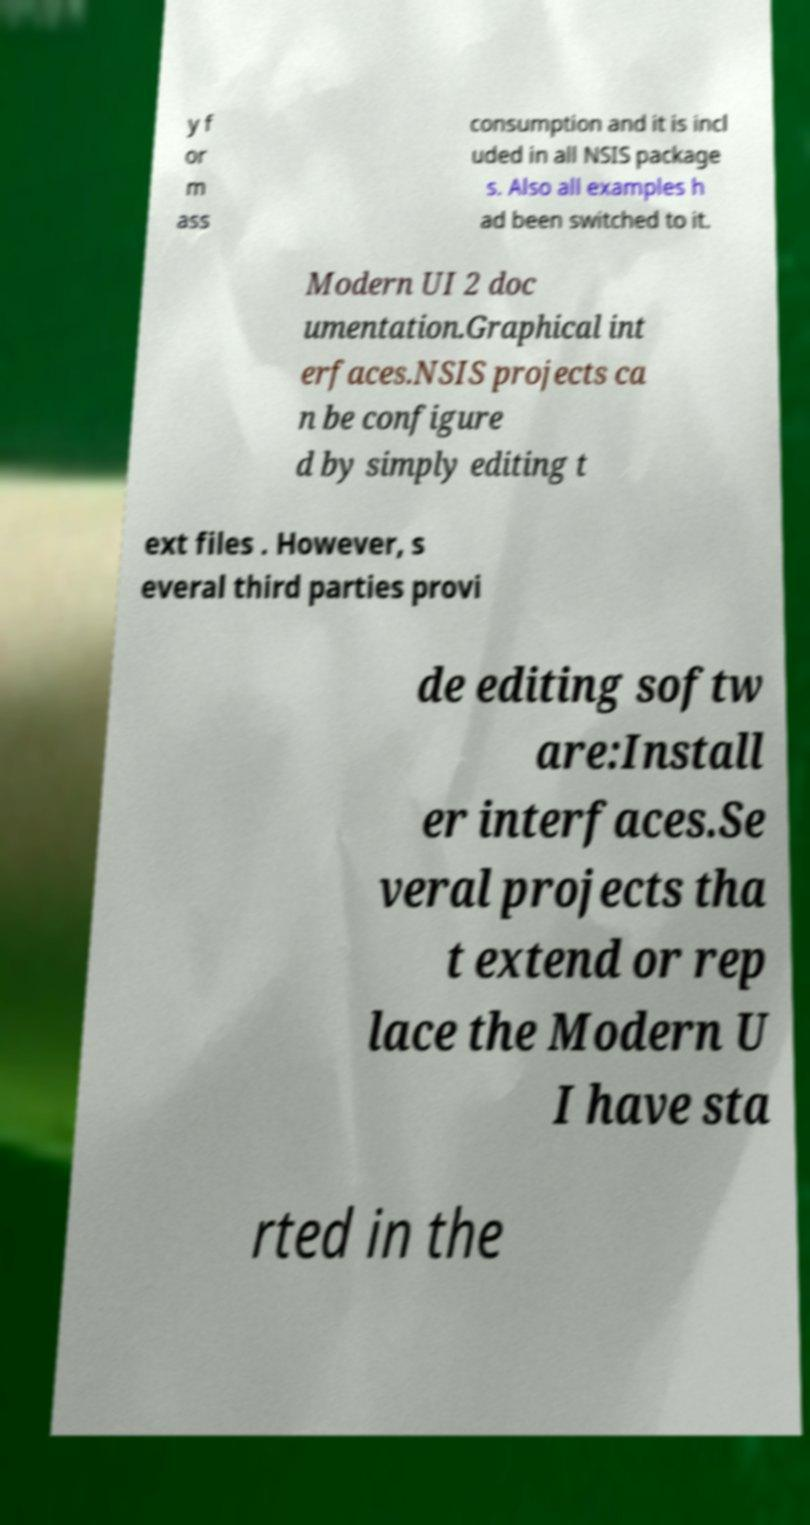Can you read and provide the text displayed in the image?This photo seems to have some interesting text. Can you extract and type it out for me? y f or m ass consumption and it is incl uded in all NSIS package s. Also all examples h ad been switched to it. Modern UI 2 doc umentation.Graphical int erfaces.NSIS projects ca n be configure d by simply editing t ext files . However, s everal third parties provi de editing softw are:Install er interfaces.Se veral projects tha t extend or rep lace the Modern U I have sta rted in the 